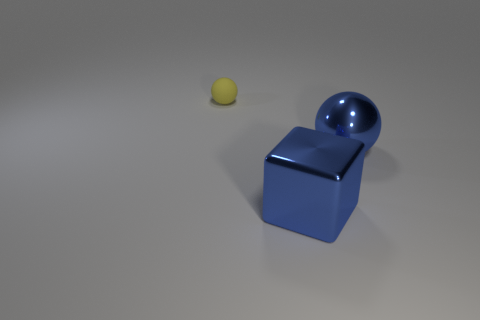Is there any other thing that is made of the same material as the yellow ball?
Ensure brevity in your answer.  No. There is a metallic thing that is the same color as the metallic sphere; what shape is it?
Make the answer very short. Cube. What is the material of the object that is left of the blue object in front of the ball in front of the tiny matte object?
Offer a very short reply. Rubber. What is the color of the ball that is left of the sphere that is in front of the small thing?
Ensure brevity in your answer.  Yellow. There is a thing that is the same size as the block; what is its color?
Ensure brevity in your answer.  Blue. What number of big objects are yellow things or metallic spheres?
Ensure brevity in your answer.  1. Is the number of blue metal blocks in front of the matte sphere greater than the number of yellow matte objects that are behind the big block?
Ensure brevity in your answer.  No. There is a metal thing that is the same color as the cube; what size is it?
Ensure brevity in your answer.  Large. How many other objects are there of the same size as the block?
Your answer should be very brief. 1. Is the material of the big thing behind the big cube the same as the cube?
Ensure brevity in your answer.  Yes. 